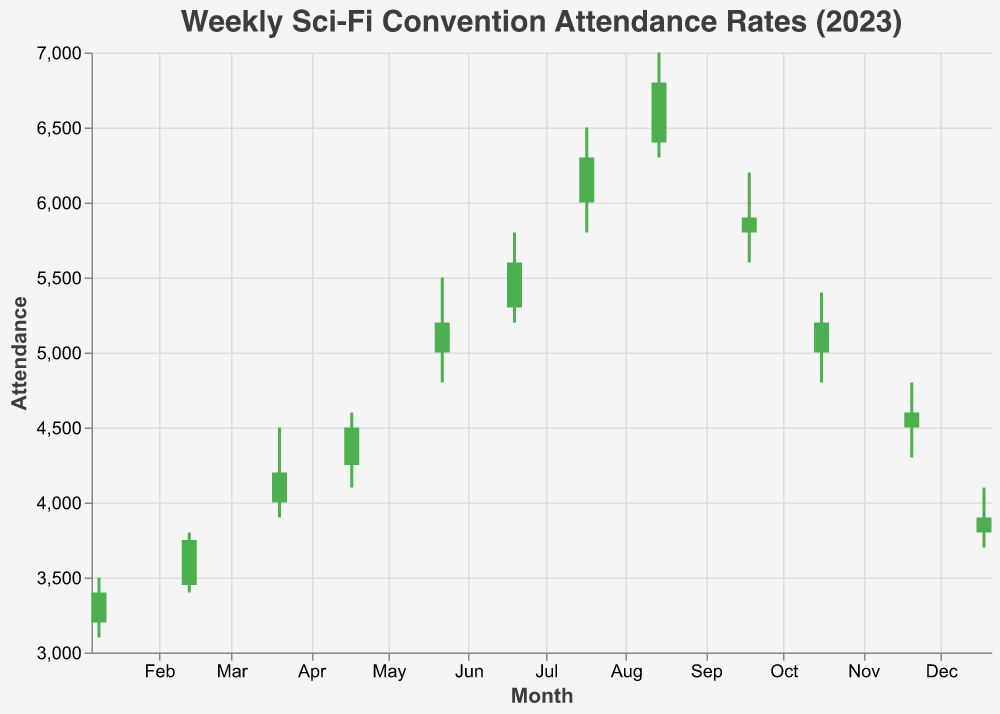What is the title of the chart? The title of the chart is prominently displayed at the top and reads "Weekly Sci-Fi Convention Attendance Rates (2023)."
Answer: Weekly Sci-Fi Convention Attendance Rates (2023) How many data points are shown for the year 2023? There is one data point for each month from January to December, which adds up to 12 data points.
Answer: 12 Which month had the highest attendance rate? The highest attendance rate is marked by the point with the highest "High" value, which is in August with a high of 7000.
Answer: August What was the attendance range (High - Low) for June? The attendance range in June is calculated by subtracting the Low value from the High value (5800 - 5200 = 600).
Answer: 600 In which month did the attendance rate increase the most compared to the previous month? To find this, we look at the difference between the Close of one month and the Open of the next month. The biggest increase is from May (Close = 5200) to June (Open = 5300), which is a gain of 100.
Answer: May to June Which months show a decrease in attendance based on their Open and Close values? Months showing a decrease will have their Close value lower than their Open value. These months are September (5800 to 5900), October (5000 to 5200), November (4500 to 4600), and December (3800 to 3900).
Answer: September, October, November, December What is the average Open value for the second half of the year (July to December)? The Open values for July to December are 6000, 6400, 5800, 5000, 4500, and 3800. Adding these values and dividing by 6 gives (6000 + 6400 + 5800 + 5000 + 4500 + 3800) / 6 = 5150.
Answer: 5150 Compare the Close value of February to that of June. Which one is higher? By directly comparing the Close values of February (3750) and June (5600), we can see that the Close value is higher in June.
Answer: June (5600) During which months did the attendance rates range between 4000 and 6000? Observing the "High" and "Low" values, the months that fit within this range are March, April, September, October, and November.
Answer: March, April, September, October, November What is the median Close value for the year 2023? To find the median, we list the Close values in ascending order: 3400, 3750, 3900, 4200, 4500, 4600, 5200, 5200, 5600, 5900, 6300, 6800. The middle values are 4500 and 4600, so the median is (4500+4600)/2 = 4550.
Answer: 4550 